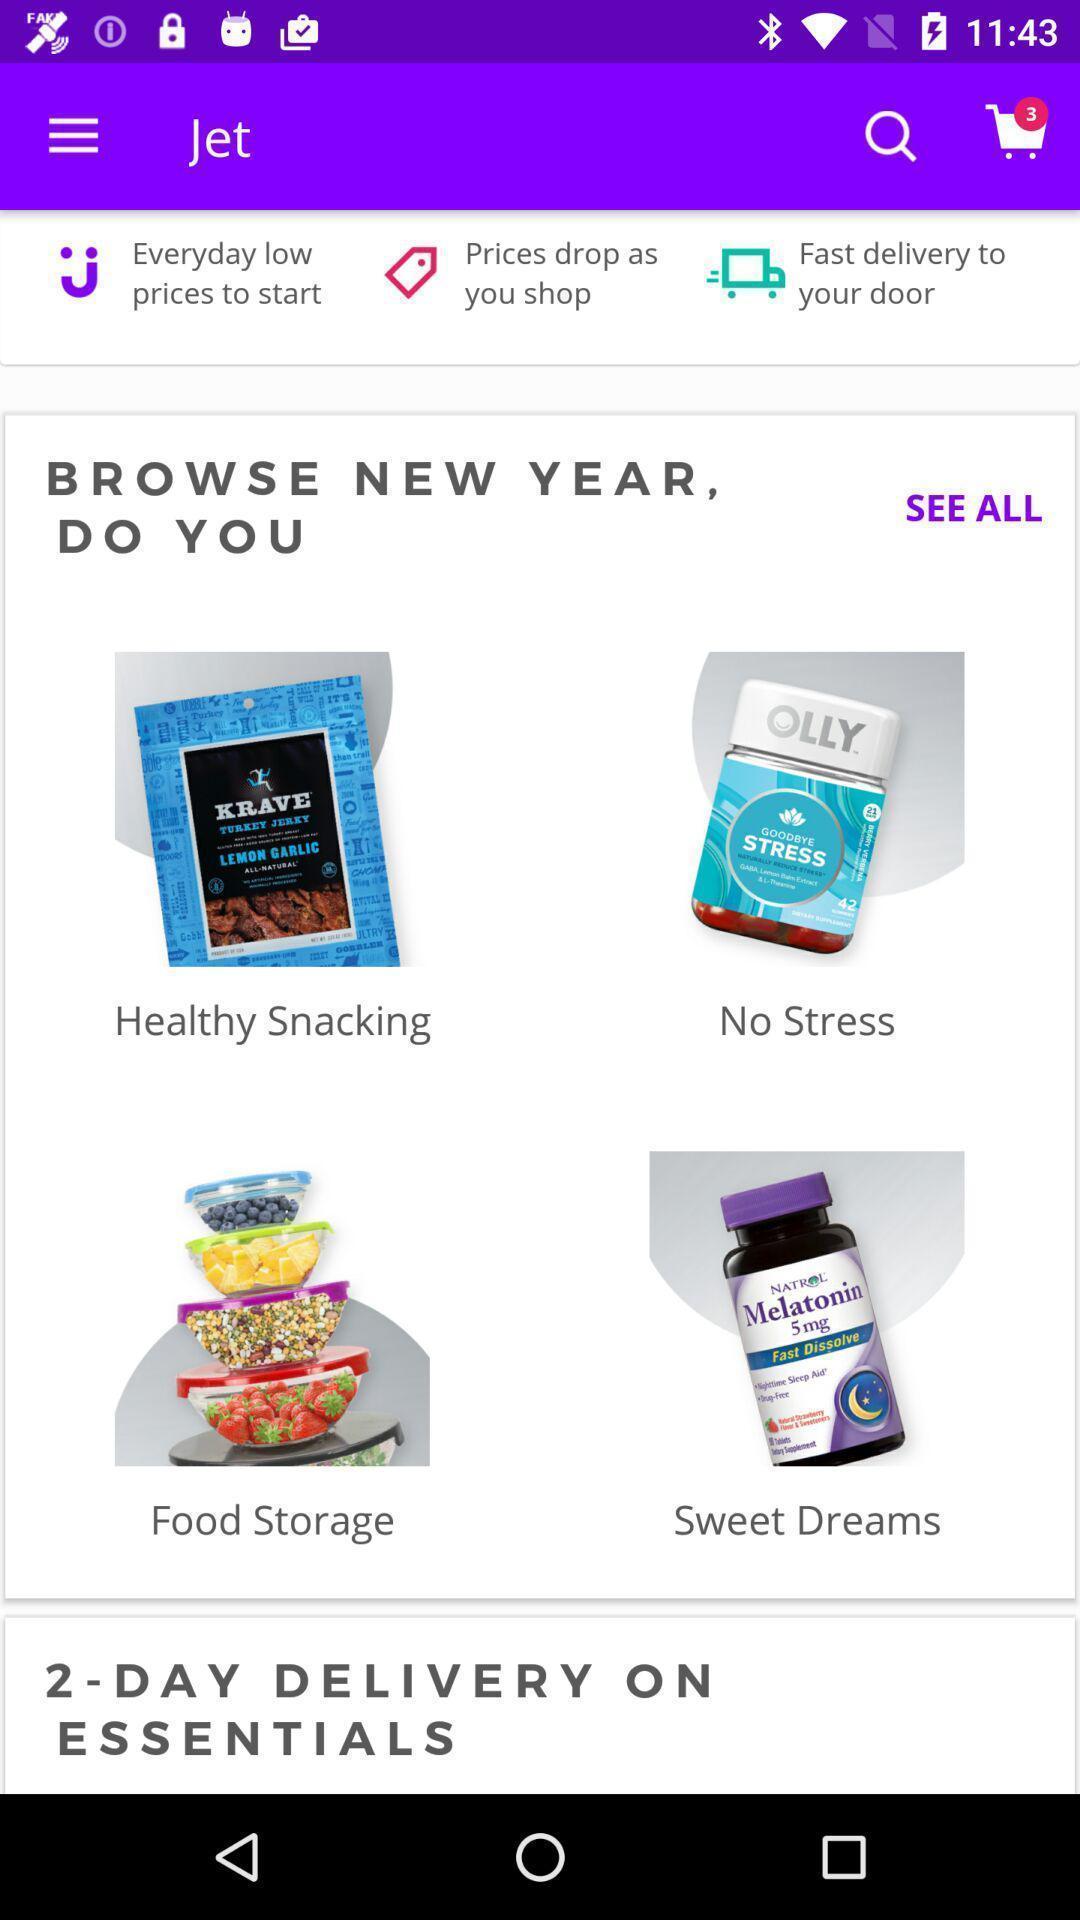Describe the key features of this screenshot. Screen displaying the page of a shopping app. 